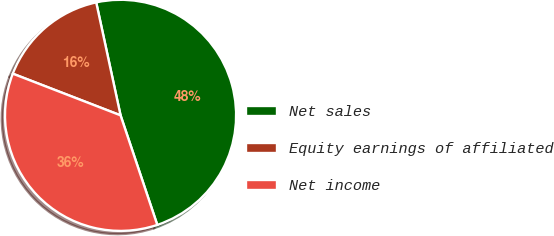Convert chart to OTSL. <chart><loc_0><loc_0><loc_500><loc_500><pie_chart><fcel>Net sales<fcel>Equity earnings of affiliated<fcel>Net income<nl><fcel>48.23%<fcel>15.75%<fcel>36.02%<nl></chart> 